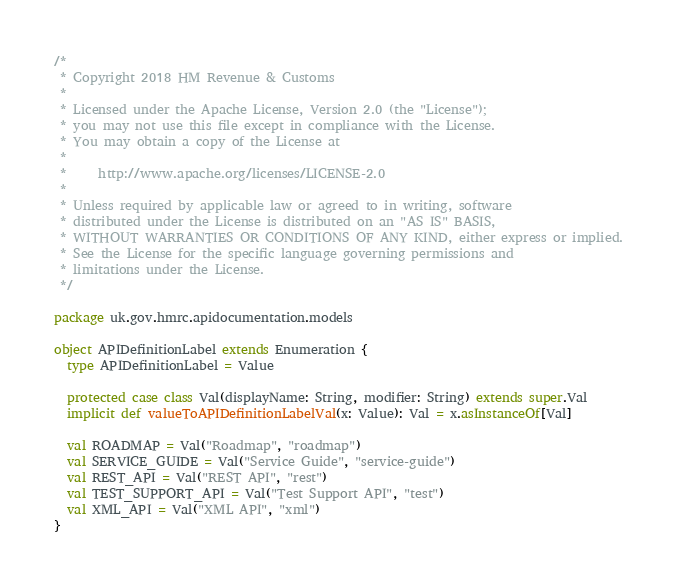<code> <loc_0><loc_0><loc_500><loc_500><_Scala_>/*
 * Copyright 2018 HM Revenue & Customs
 *
 * Licensed under the Apache License, Version 2.0 (the "License");
 * you may not use this file except in compliance with the License.
 * You may obtain a copy of the License at
 *
 *     http://www.apache.org/licenses/LICENSE-2.0
 *
 * Unless required by applicable law or agreed to in writing, software
 * distributed under the License is distributed on an "AS IS" BASIS,
 * WITHOUT WARRANTIES OR CONDITIONS OF ANY KIND, either express or implied.
 * See the License for the specific language governing permissions and
 * limitations under the License.
 */

package uk.gov.hmrc.apidocumentation.models

object APIDefinitionLabel extends Enumeration {
  type APIDefinitionLabel = Value

  protected case class Val(displayName: String, modifier: String) extends super.Val
  implicit def valueToAPIDefinitionLabelVal(x: Value): Val = x.asInstanceOf[Val]

  val ROADMAP = Val("Roadmap", "roadmap")
  val SERVICE_GUIDE = Val("Service Guide", "service-guide")
  val REST_API = Val("REST API", "rest")
  val TEST_SUPPORT_API = Val("Test Support API", "test")
  val XML_API = Val("XML API", "xml")
}
</code> 